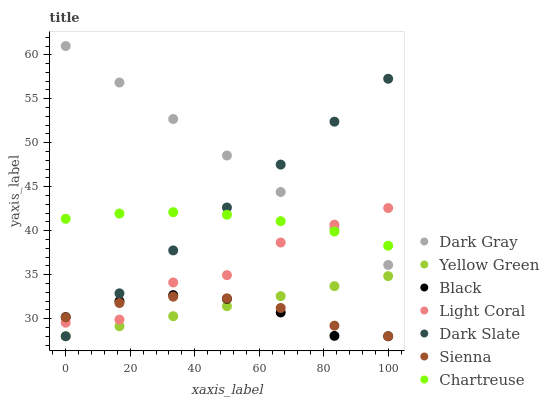Does Black have the minimum area under the curve?
Answer yes or no. Yes. Does Dark Gray have the maximum area under the curve?
Answer yes or no. Yes. Does Yellow Green have the minimum area under the curve?
Answer yes or no. No. Does Yellow Green have the maximum area under the curve?
Answer yes or no. No. Is Yellow Green the smoothest?
Answer yes or no. Yes. Is Light Coral the roughest?
Answer yes or no. Yes. Is Dark Slate the smoothest?
Answer yes or no. No. Is Dark Slate the roughest?
Answer yes or no. No. Does Yellow Green have the lowest value?
Answer yes or no. Yes. Does Dark Gray have the lowest value?
Answer yes or no. No. Does Dark Gray have the highest value?
Answer yes or no. Yes. Does Yellow Green have the highest value?
Answer yes or no. No. Is Yellow Green less than Dark Gray?
Answer yes or no. Yes. Is Chartreuse greater than Sienna?
Answer yes or no. Yes. Does Sienna intersect Yellow Green?
Answer yes or no. Yes. Is Sienna less than Yellow Green?
Answer yes or no. No. Is Sienna greater than Yellow Green?
Answer yes or no. No. Does Yellow Green intersect Dark Gray?
Answer yes or no. No. 